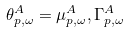<formula> <loc_0><loc_0><loc_500><loc_500>\theta _ { p , \omega } ^ { A } = \mu _ { p , \omega } ^ { A } , \Gamma _ { p , \omega } ^ { A }</formula> 